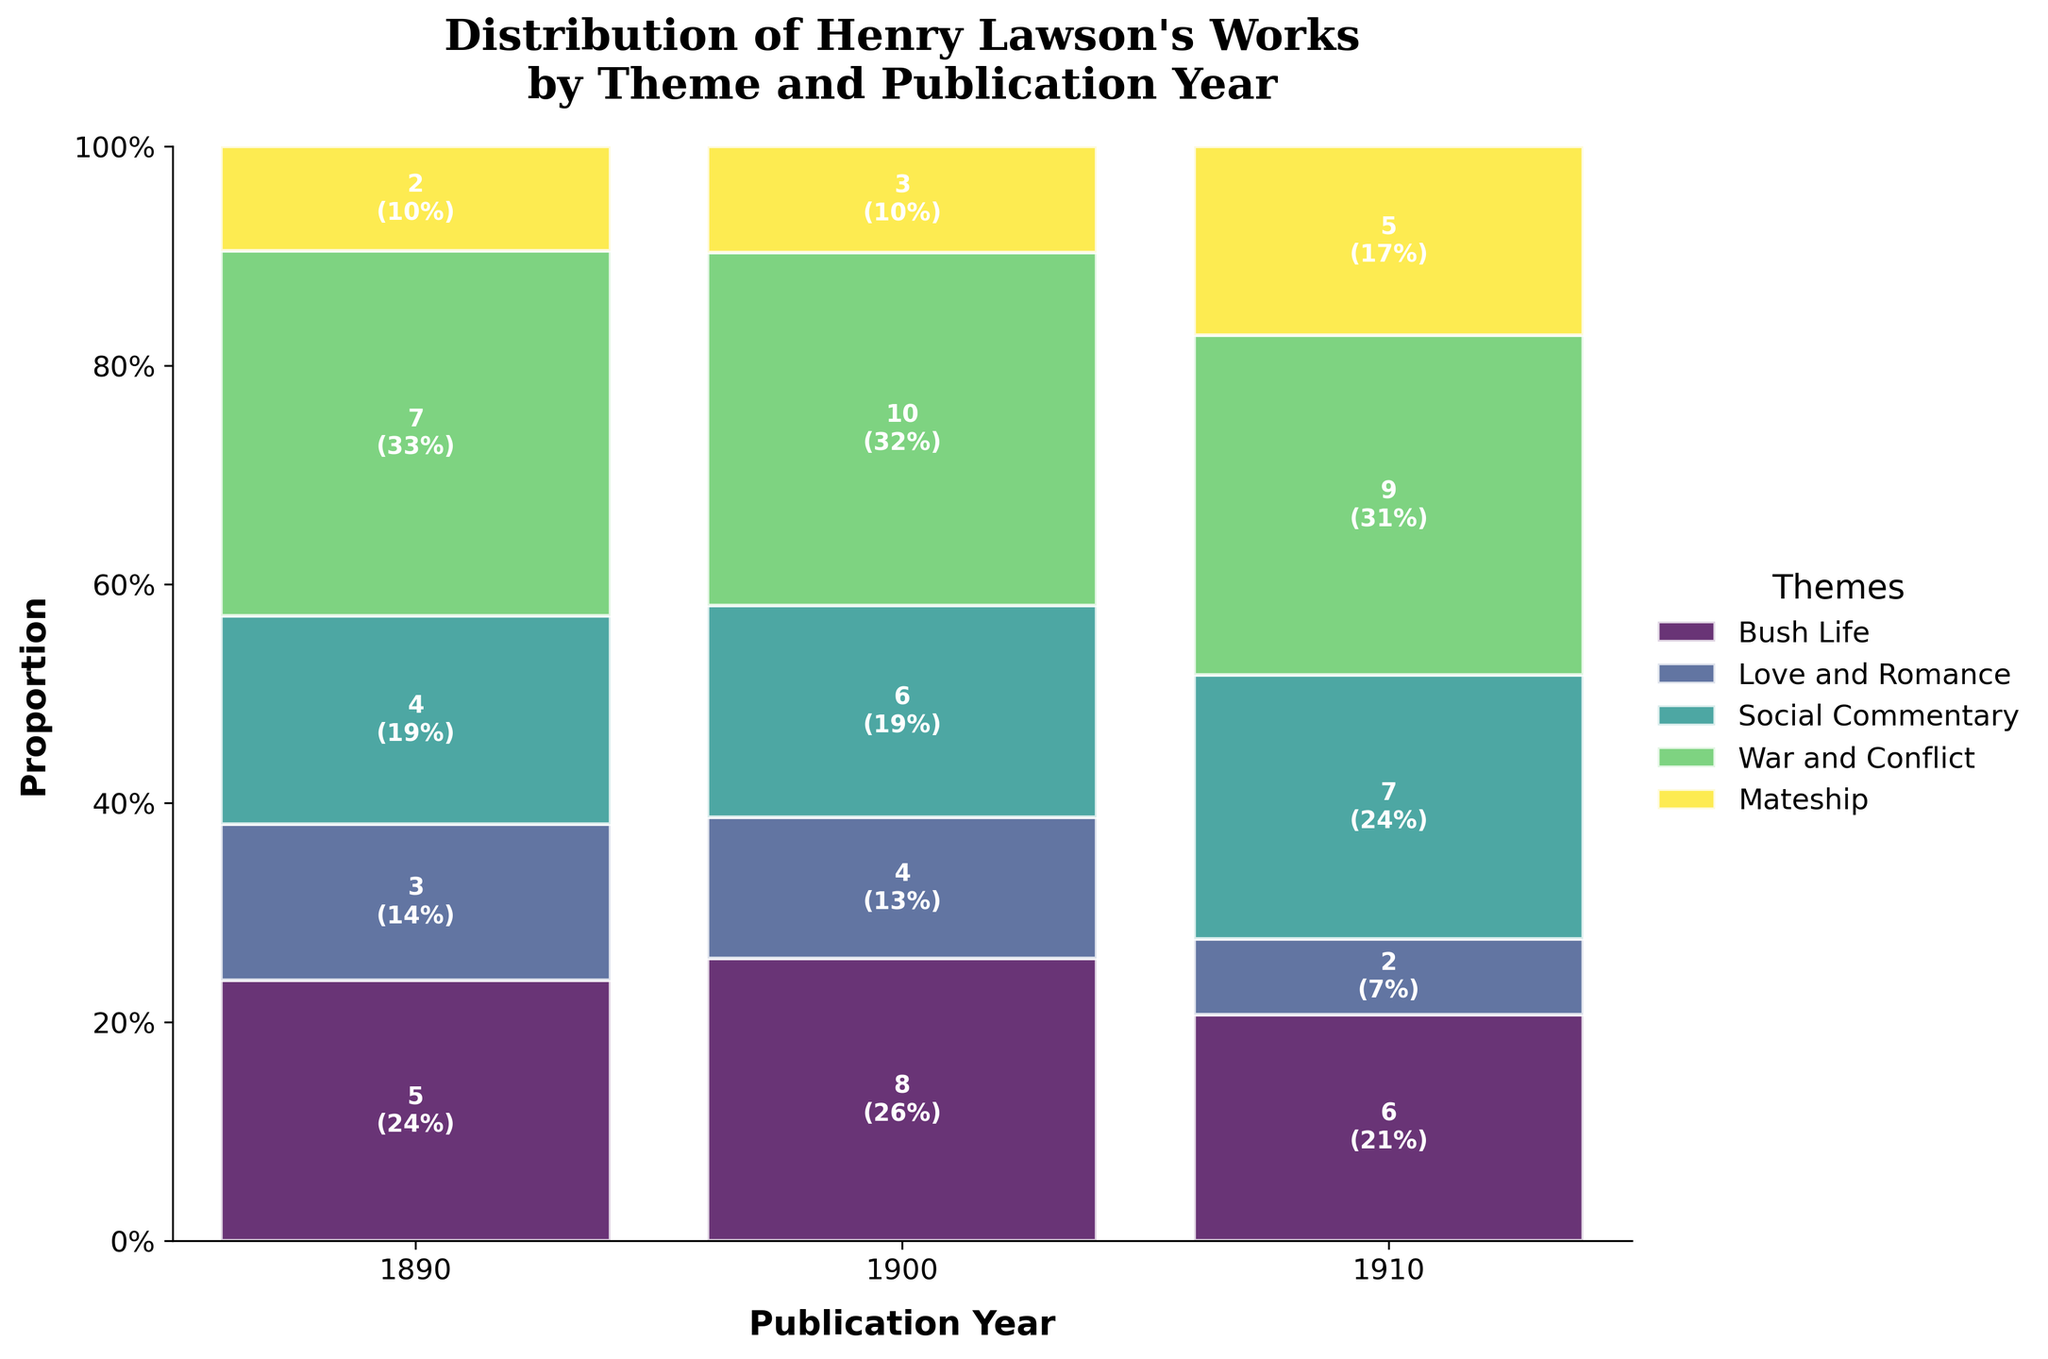How many works related to 'War and Conflict' were published in 1910? Look at the 'War and Conflict' theme and find the bar corresponding to the year 1910. According to the label, it shows 5 works.
Answer: 5 Which theme had the highest number of works published in 1900? Compare the height of each thematic bar for the year 1900. The 'Social Commentary' theme has the highest bar, indicating the largest count of 10 works.
Answer: Social Commentary Between 1890 and 1910, which year had the lowest proportion of works related to 'Love and Romance'? Compare the sizes (heights) of the 'Love and Romance' bars across all years. The smallest proportion is in 1910, showing 2 works.
Answer: 1910 By what percentage did the count of 'Mateship' works change from 1890 to 1910? 'Mateship' theme had 4 works in 1890 and 7 in 1910. The change is (7-4)/4*100% which equals 75%.
Answer: 75% How many more 'Bush Life' works were published in 1900 compared to 1890? 'Bush Life' theme had 8 works in 1900 and 5 in 1890. The difference is 8 - 5 which equals 3.
Answer: 3 What can you infer about the trend of 'Social Commentary' works over the years? Inspect the 'Social Commentary' bars across the years 1890, 1900, and 1910. The counts go 7, 10, and 9, indicating a rise from 1890 to 1900 and a slight drop from 1900 to 1910.
Answer: Initial increase then slight decrease Compare the proportions of 'Bush Life' and 'Love and Romance' themes in 1910. Which is higher? Look at the thematic bars for 1910. 'Bush Life' has 6 works while 'Love and Romance' has 2. The proportion of 'Bush Life' is higher.
Answer: Bush Life What total number of works did Henry Lawson publish in 1900 across all themes? Sum the counts in 1900: Bush Life (8), Love and Romance (4), Social Commentary (10), War and Conflict (3), and Mateship (6). The total is 8 + 4 + 10 + 3 + 6 which equals 31.
Answer: 31 Which theme shows the most constancy in number of works published across the three years? Review the variance in bar heights for each theme across 1890, 1900, and 1910. 'War and Conflict' has relatively smaller changes (2, 3, and 5).
Answer: War and Conflict 